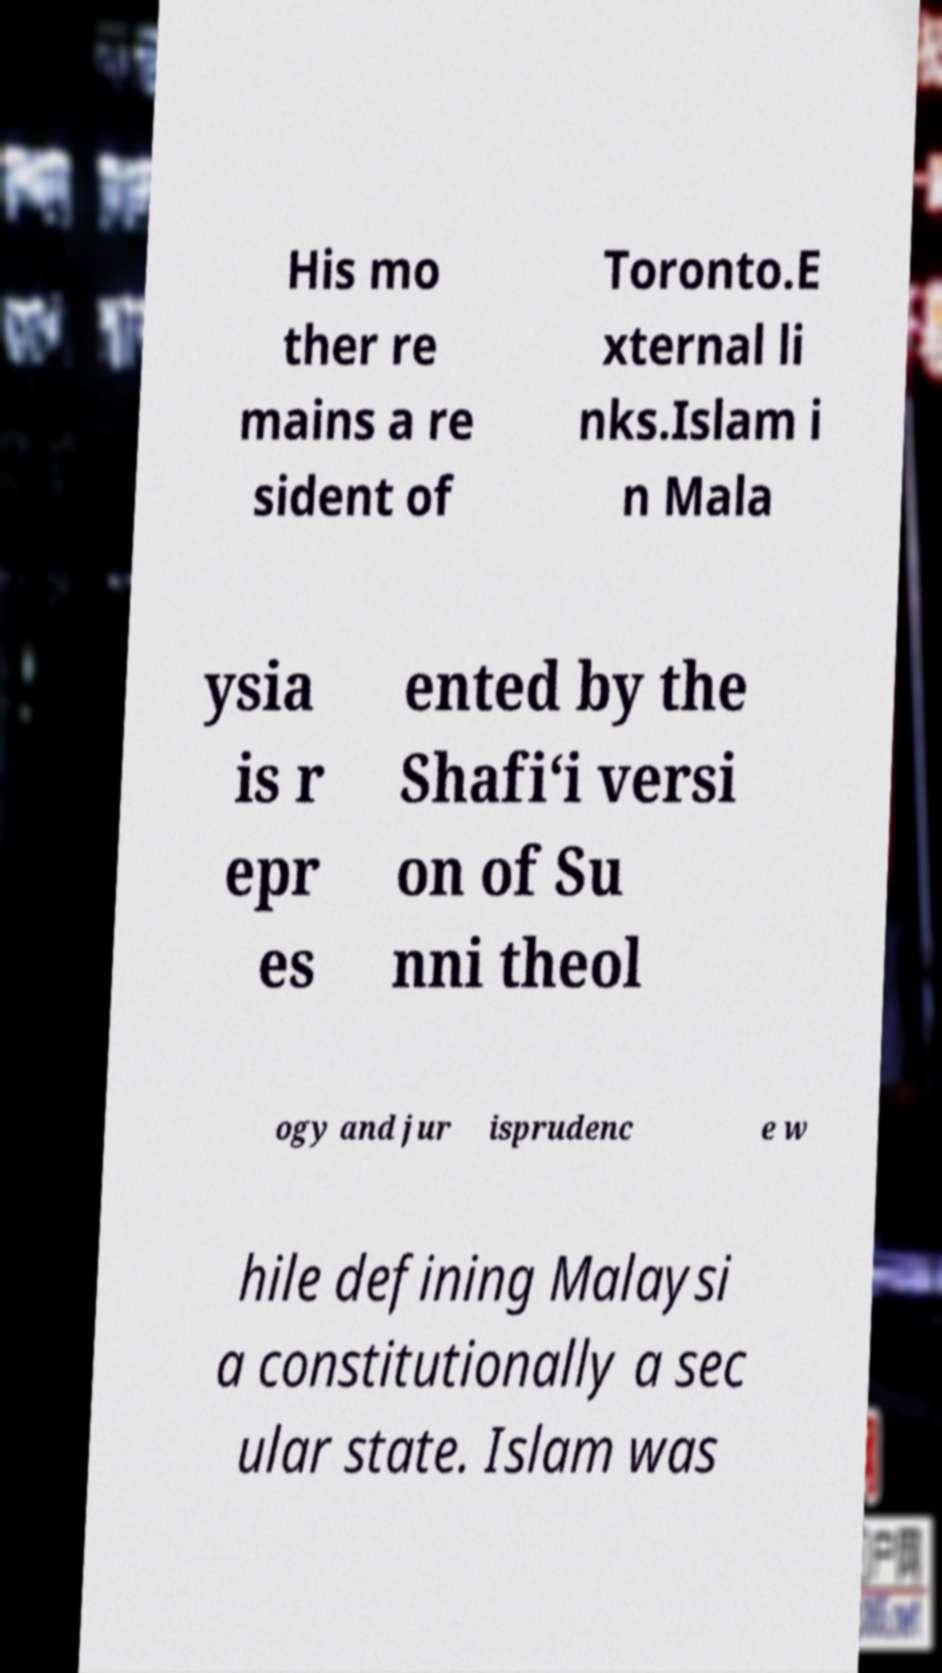Could you extract and type out the text from this image? His mo ther re mains a re sident of Toronto.E xternal li nks.Islam i n Mala ysia is r epr es ented by the Shafi‘i versi on of Su nni theol ogy and jur isprudenc e w hile defining Malaysi a constitutionally a sec ular state. Islam was 